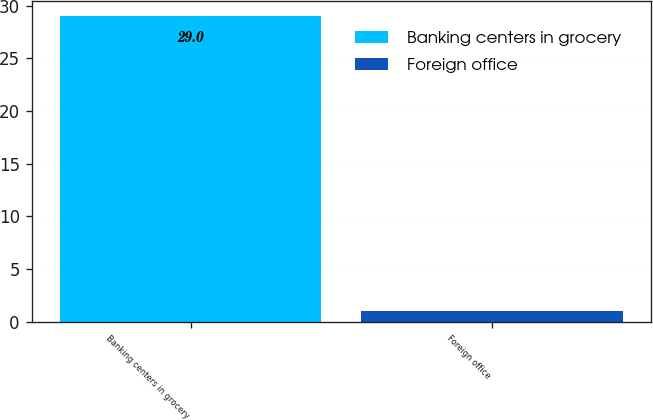Convert chart to OTSL. <chart><loc_0><loc_0><loc_500><loc_500><bar_chart><fcel>Banking centers in grocery<fcel>Foreign office<nl><fcel>29<fcel>1<nl></chart> 